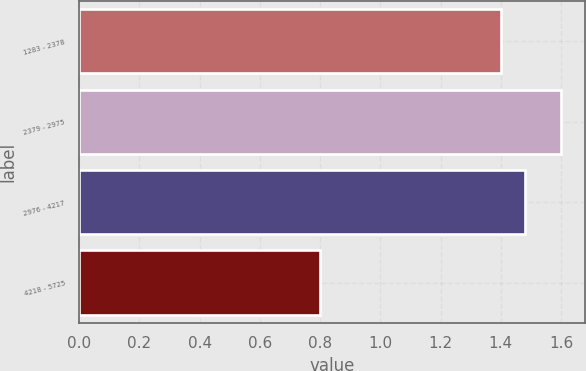Convert chart. <chart><loc_0><loc_0><loc_500><loc_500><bar_chart><fcel>1283 - 2378<fcel>2379 - 2975<fcel>2976 - 4217<fcel>4218 - 5725<nl><fcel>1.4<fcel>1.6<fcel>1.48<fcel>0.8<nl></chart> 